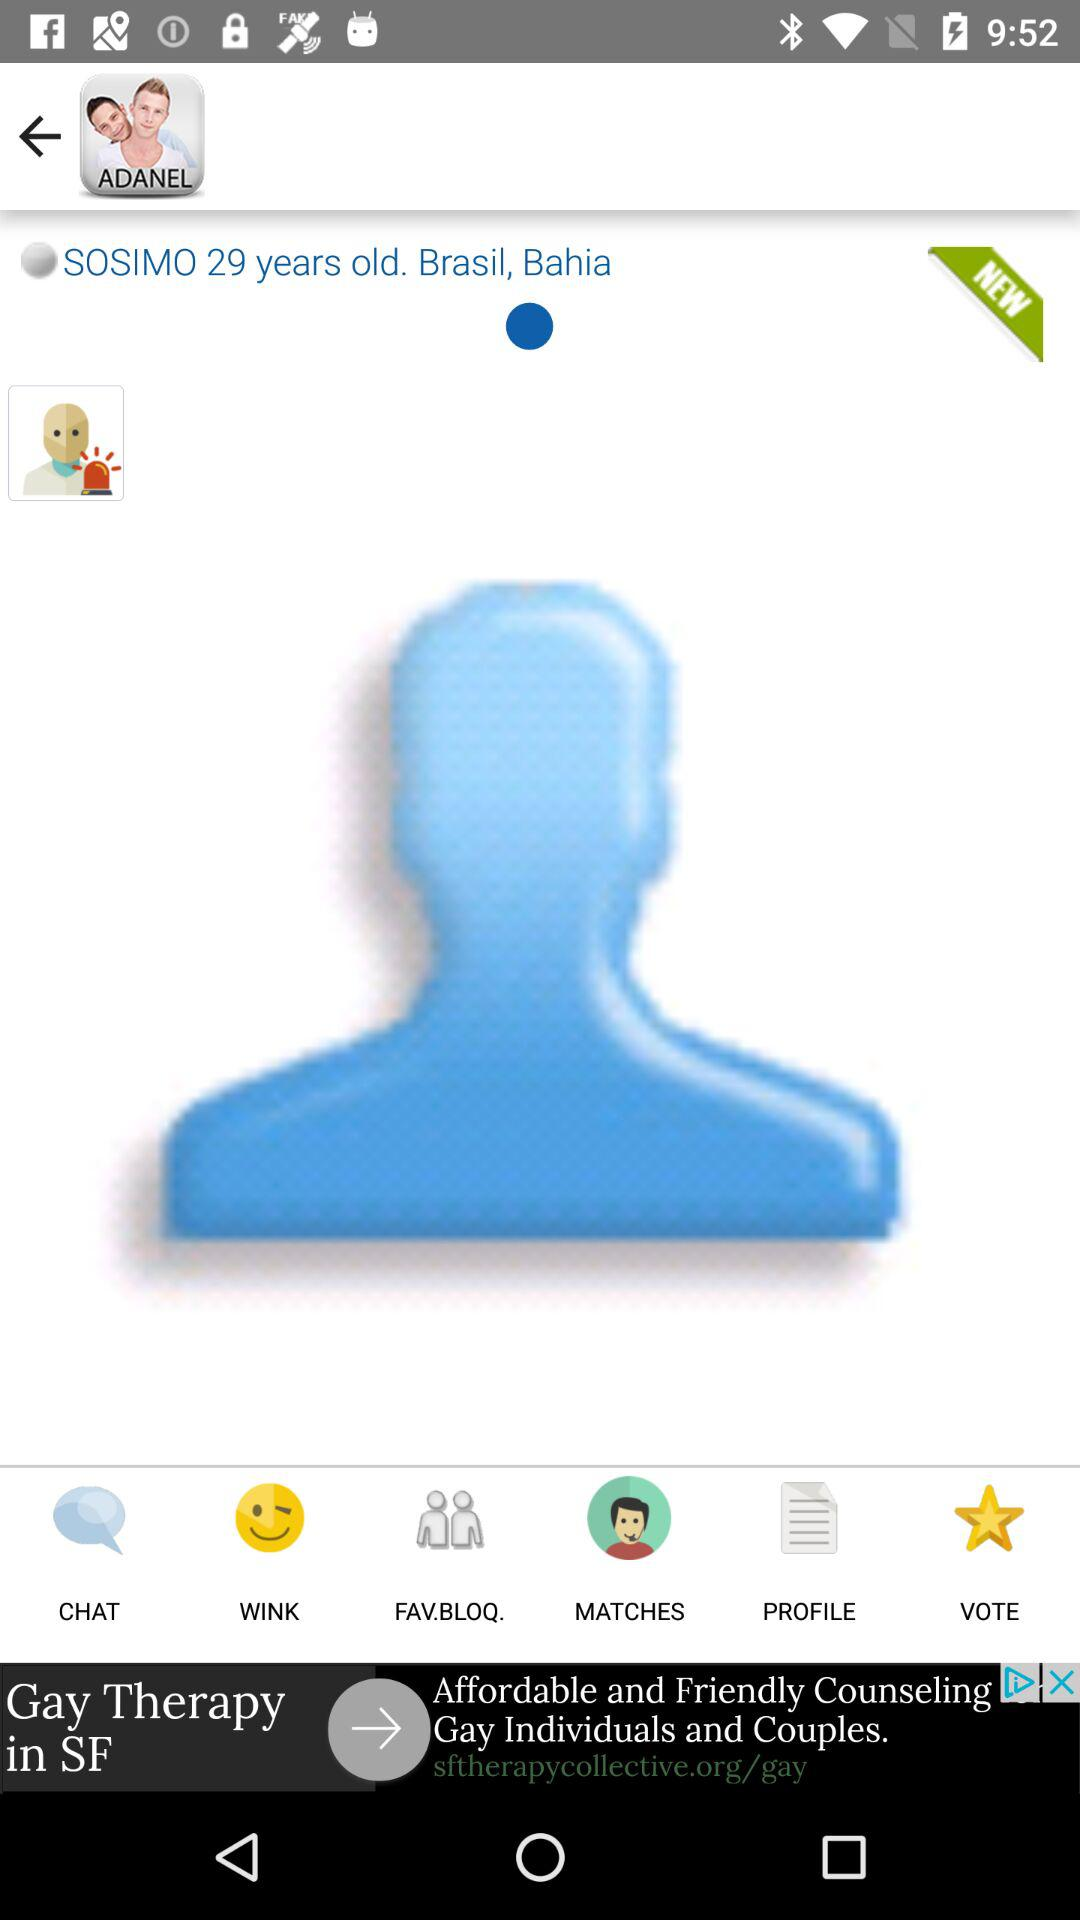What is the name of the person? The name of the person is Sosimo. 